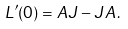<formula> <loc_0><loc_0><loc_500><loc_500>L ^ { \prime } ( 0 ) = A J - J A \, .</formula> 